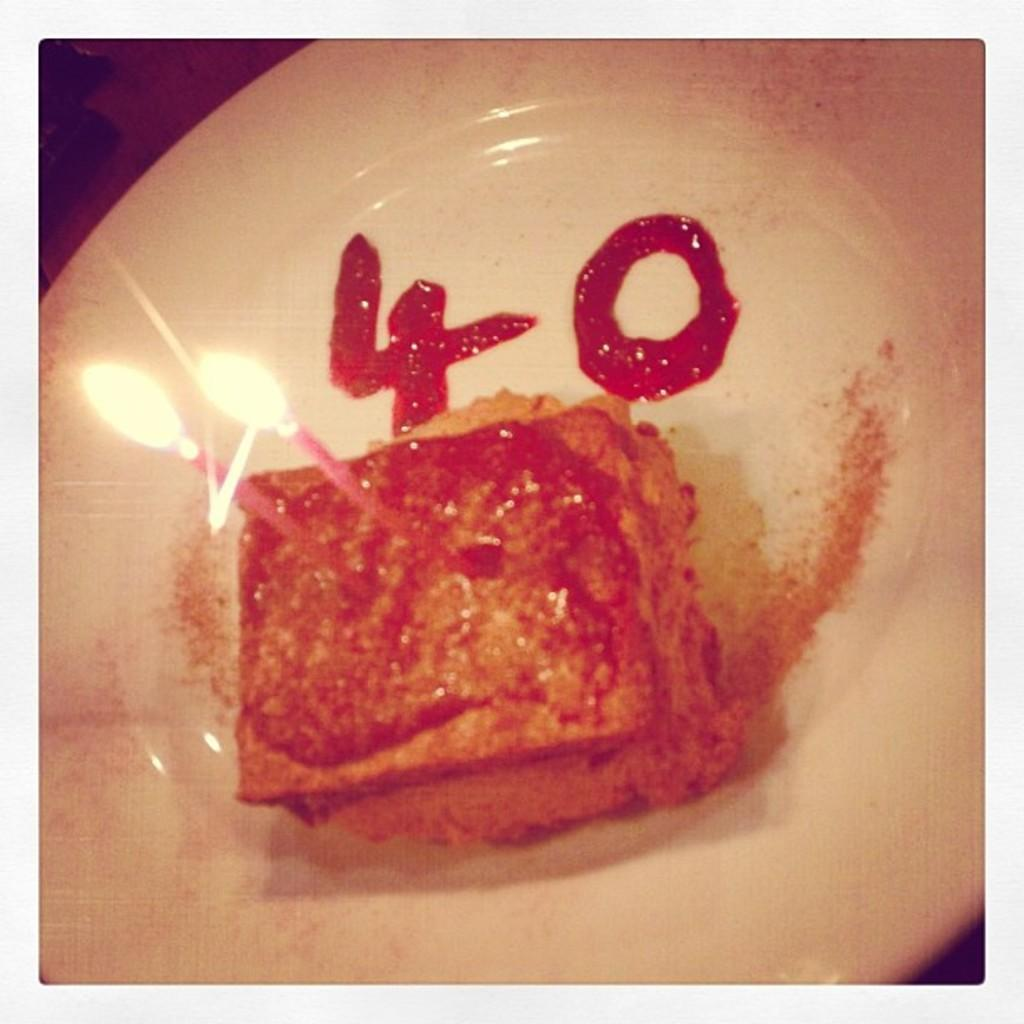What is the main subject of the image? There is a cake in the image. Are there any decorations on the cake? Yes, the cake has two candles on it. What is written on the plate next to the cake? The numbers four and zero are written with jam on the plate. What type of zinc is used to make the candles on the cake? There is no mention of zinc or the material used for the candles in the image. The candles are simply described as being on the cake. 